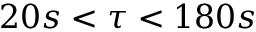<formula> <loc_0><loc_0><loc_500><loc_500>2 0 s < \tau < 1 8 0 s</formula> 